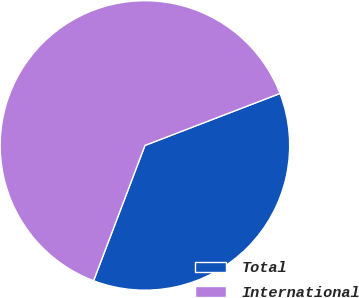Convert chart. <chart><loc_0><loc_0><loc_500><loc_500><pie_chart><fcel>Total<fcel>International<nl><fcel>36.62%<fcel>63.38%<nl></chart> 